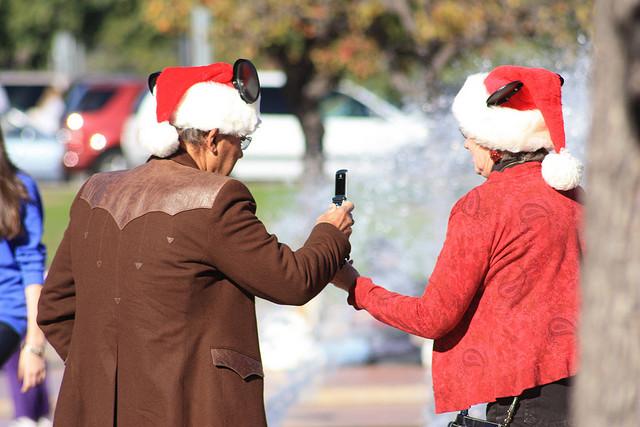What is the couple holding?
Concise answer only. Phone. Are these people wearing Santa hats?
Concise answer only. Yes. Are this Santa hats?
Concise answer only. Yes. 